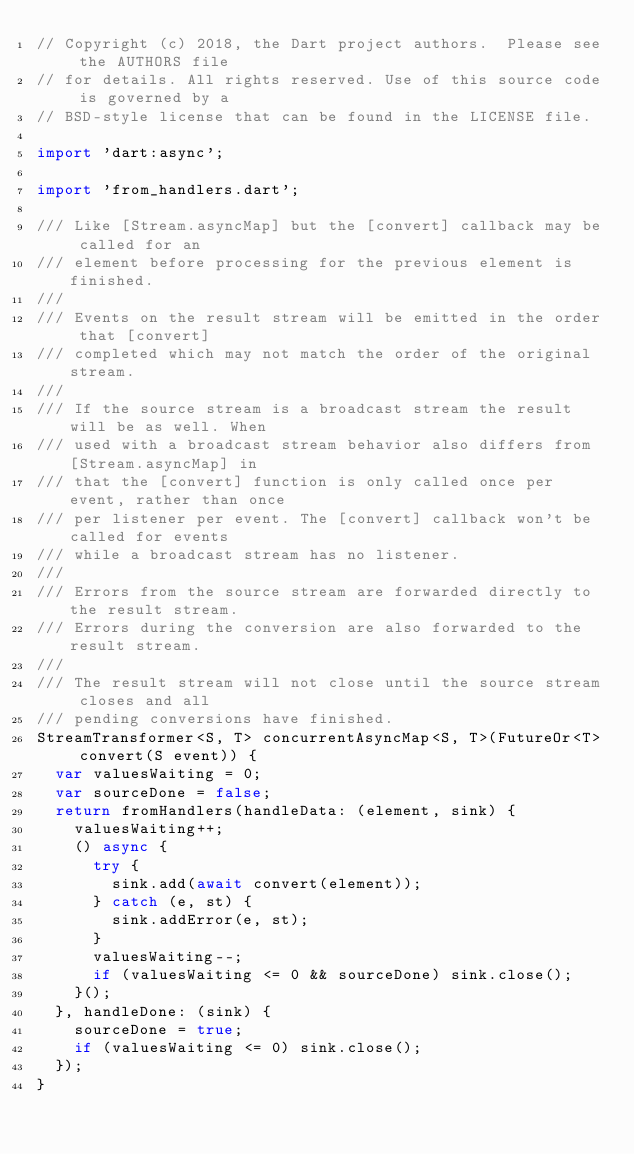<code> <loc_0><loc_0><loc_500><loc_500><_Dart_>// Copyright (c) 2018, the Dart project authors.  Please see the AUTHORS file
// for details. All rights reserved. Use of this source code is governed by a
// BSD-style license that can be found in the LICENSE file.

import 'dart:async';

import 'from_handlers.dart';

/// Like [Stream.asyncMap] but the [convert] callback may be called for an
/// element before processing for the previous element is finished.
///
/// Events on the result stream will be emitted in the order that [convert]
/// completed which may not match the order of the original stream.
///
/// If the source stream is a broadcast stream the result will be as well. When
/// used with a broadcast stream behavior also differs from [Stream.asyncMap] in
/// that the [convert] function is only called once per event, rather than once
/// per listener per event. The [convert] callback won't be called for events
/// while a broadcast stream has no listener.
///
/// Errors from the source stream are forwarded directly to the result stream.
/// Errors during the conversion are also forwarded to the result stream.
///
/// The result stream will not close until the source stream closes and all
/// pending conversions have finished.
StreamTransformer<S, T> concurrentAsyncMap<S, T>(FutureOr<T> convert(S event)) {
  var valuesWaiting = 0;
  var sourceDone = false;
  return fromHandlers(handleData: (element, sink) {
    valuesWaiting++;
    () async {
      try {
        sink.add(await convert(element));
      } catch (e, st) {
        sink.addError(e, st);
      }
      valuesWaiting--;
      if (valuesWaiting <= 0 && sourceDone) sink.close();
    }();
  }, handleDone: (sink) {
    sourceDone = true;
    if (valuesWaiting <= 0) sink.close();
  });
}
</code> 